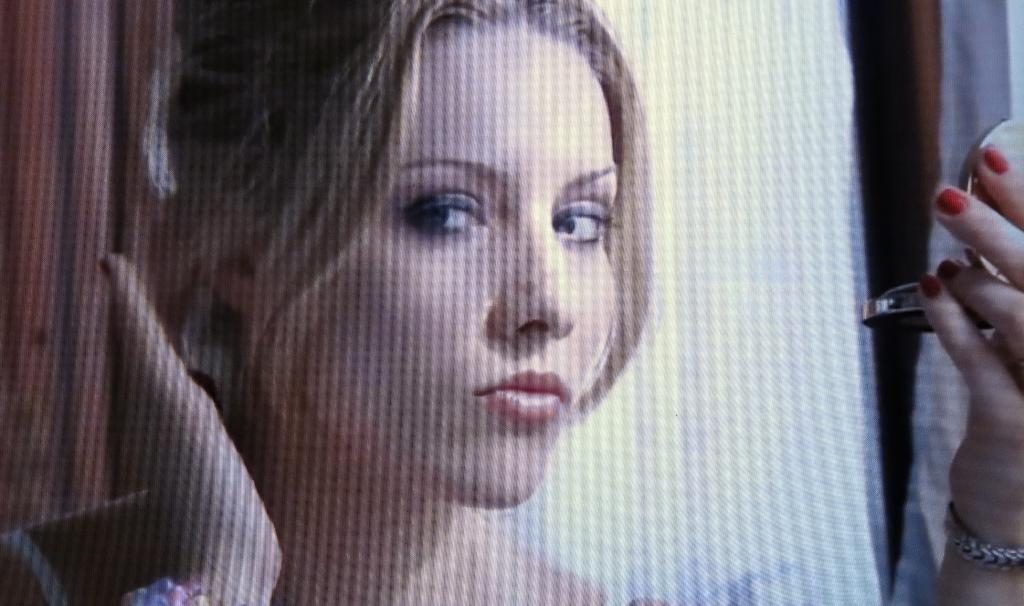Who is the main subject in the image? There is a woman in the image. What is the woman holding in the image? The woman is holding a mirror. Which hand is the woman using to hold the mirror? The woman is using her left hand to hold the mirror. What type of polish is the woman applying to the canvas in the image? There is no canvas or polish present in the image; it features a woman holding a mirror. 